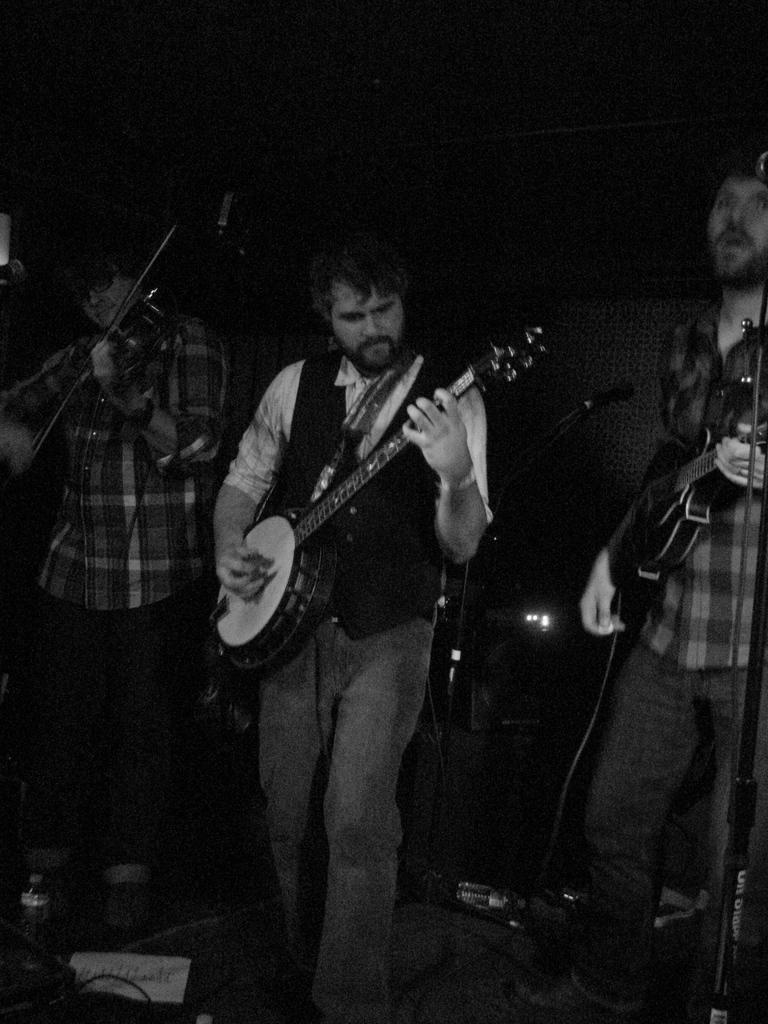How many people are in the image? There are three men in the image. What are the men doing in the image? The men are standing and holding a guitar. What can be seen in the background of the image? There is a wall in the background of the image. What type of farm animals can be seen in the image? There are no farm animals present in the image. What yard work are the men performing in the image? The men are not performing any yard work in the image; they are holding a guitar. 